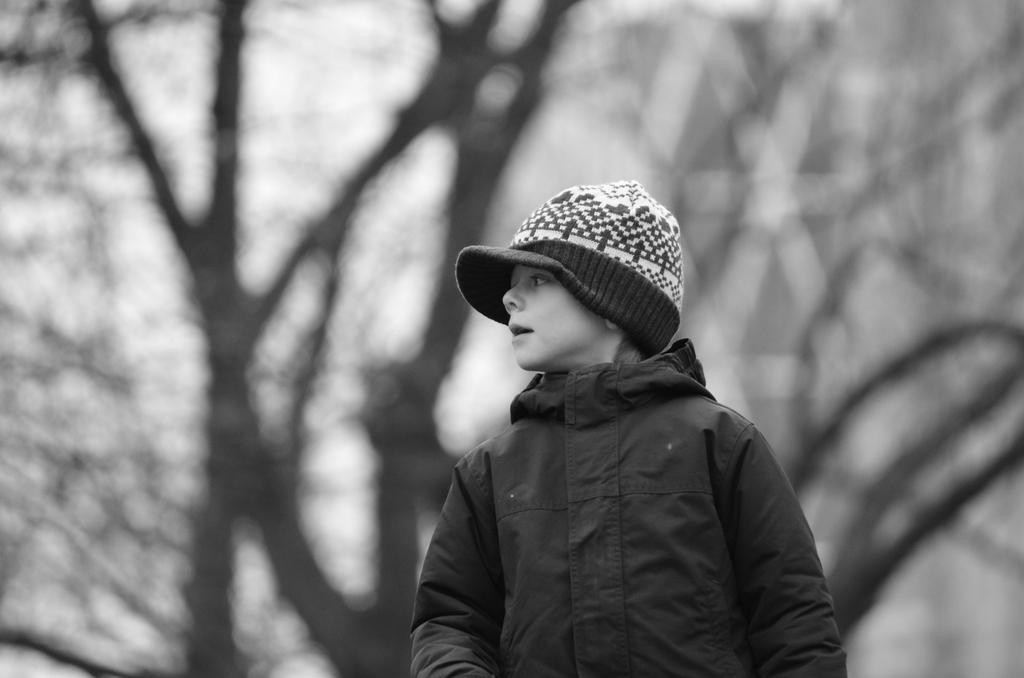What is the main subject of the image? There is a boy in the center of the image. What is the boy doing in the image? The boy is standing. What is the boy wearing on his head? The boy is wearing a hat. What can be seen in the background of the image? There are trees in the background of the image. What type of fuel is the boy using to power his bicycle in the image? There is no bicycle present in the image, and therefore no fuel is being used. 